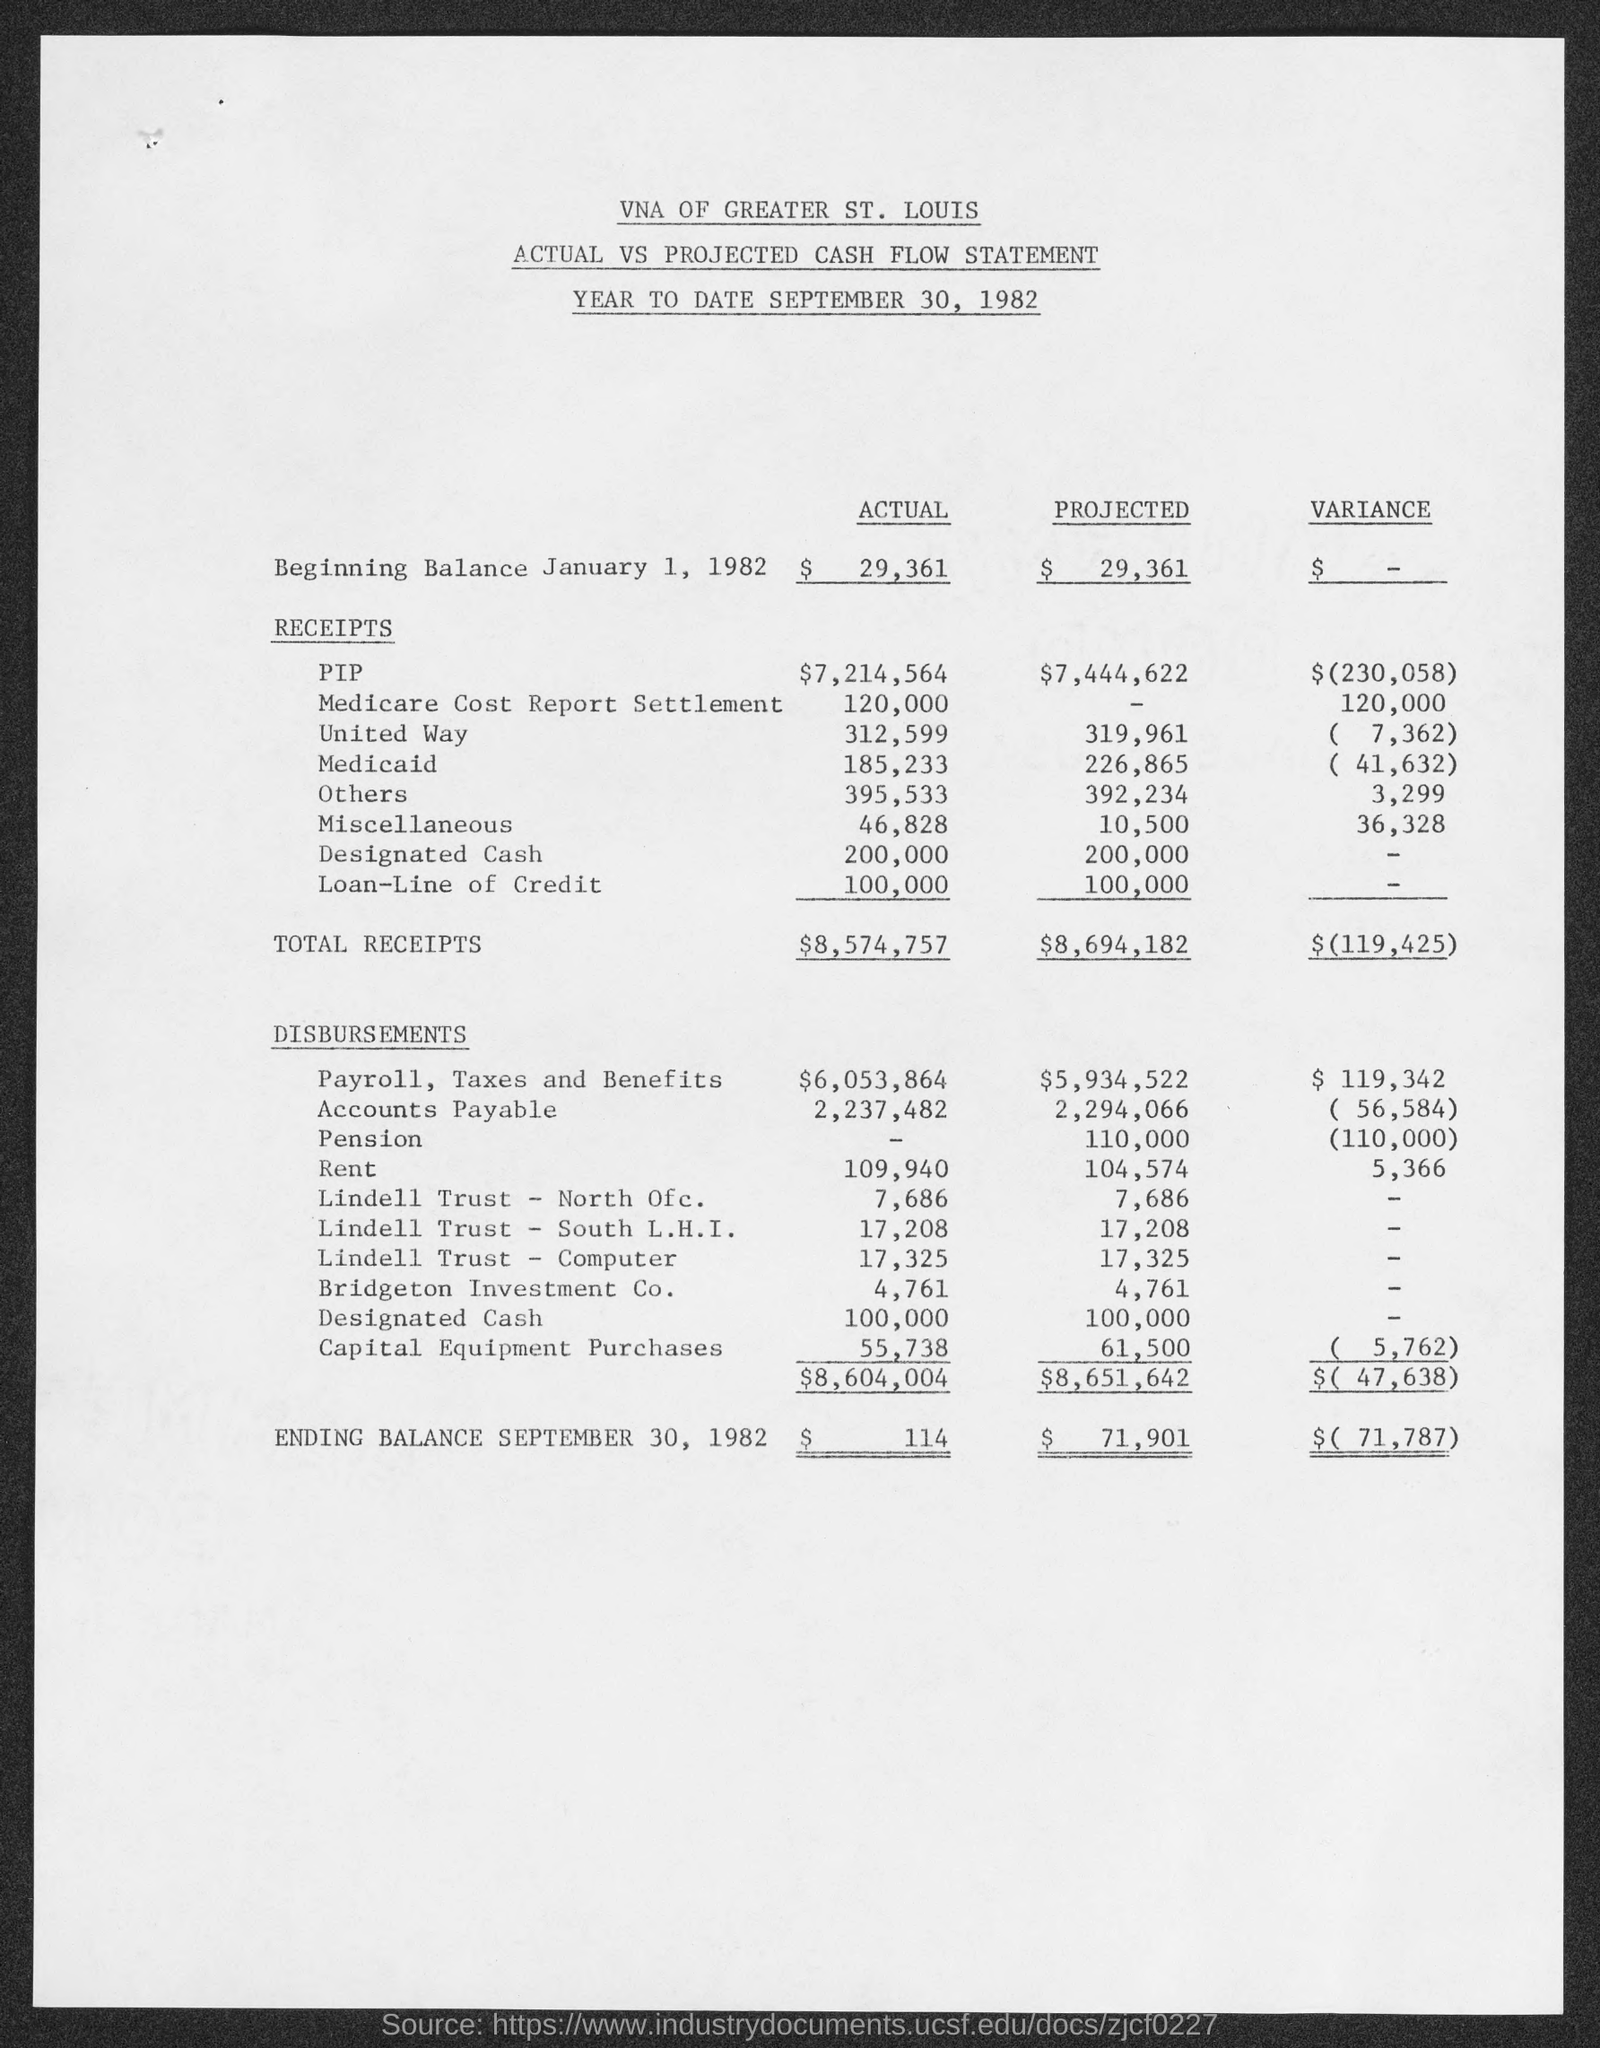Draw attention to some important aspects in this diagram. The actual designated cash amount is 200,000. The actual amount is 312,599. The beginning balance date is January 1, 1982. The actual PIP amount is $7,214,564. The projected PIP is expected to be $7,444,622. 